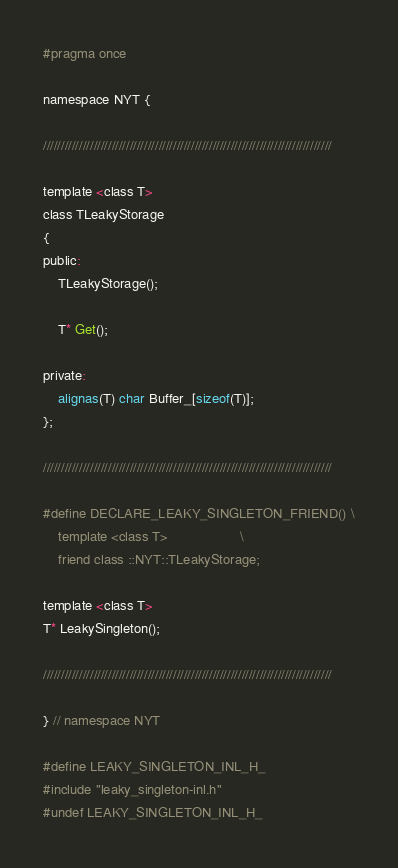<code> <loc_0><loc_0><loc_500><loc_500><_C_>#pragma once

namespace NYT {

////////////////////////////////////////////////////////////////////////////////

template <class T>
class TLeakyStorage
{
public:
    TLeakyStorage();

    T* Get();

private:
    alignas(T) char Buffer_[sizeof(T)];
};

////////////////////////////////////////////////////////////////////////////////

#define DECLARE_LEAKY_SINGLETON_FRIEND() \
    template <class T>                   \
    friend class ::NYT::TLeakyStorage;

template <class T>
T* LeakySingleton();

////////////////////////////////////////////////////////////////////////////////

} // namespace NYT

#define LEAKY_SINGLETON_INL_H_
#include "leaky_singleton-inl.h"
#undef LEAKY_SINGLETON_INL_H_
</code> 